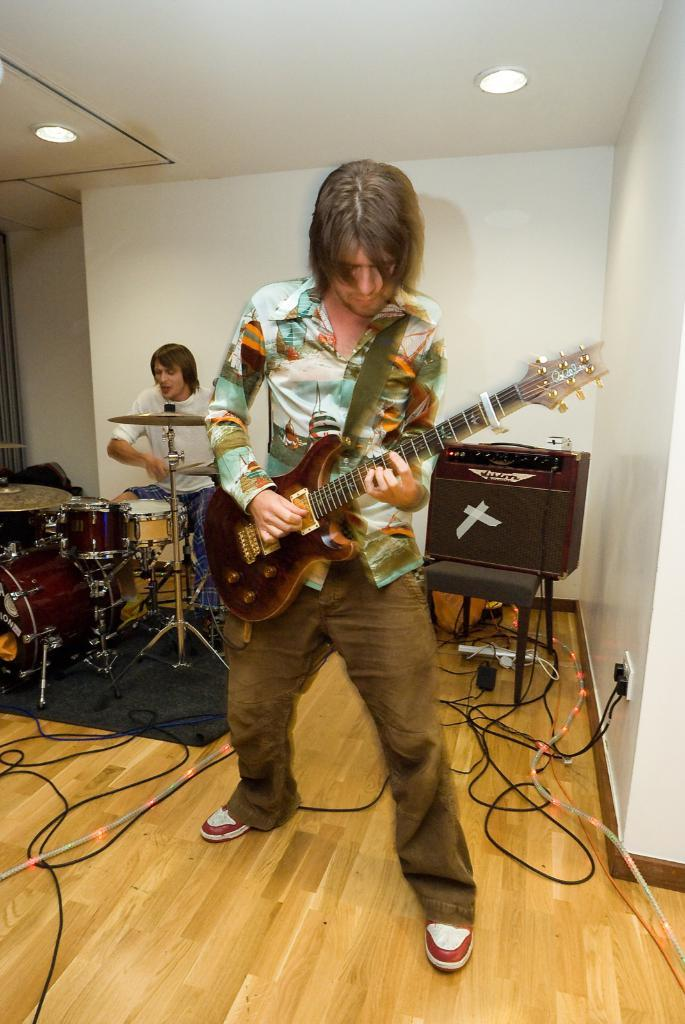How many people are in the image? There are two persons in the image. What are the two persons holding? One person is holding a guitar, and the other person is holding a stick. What can be inferred about the scene from the presence of a guitar and a stick? There is a musical band in the image. What type of vase is being used as a percussion instrument in the image? There is no vase present in the image, and no percussion instruments are mentioned. 